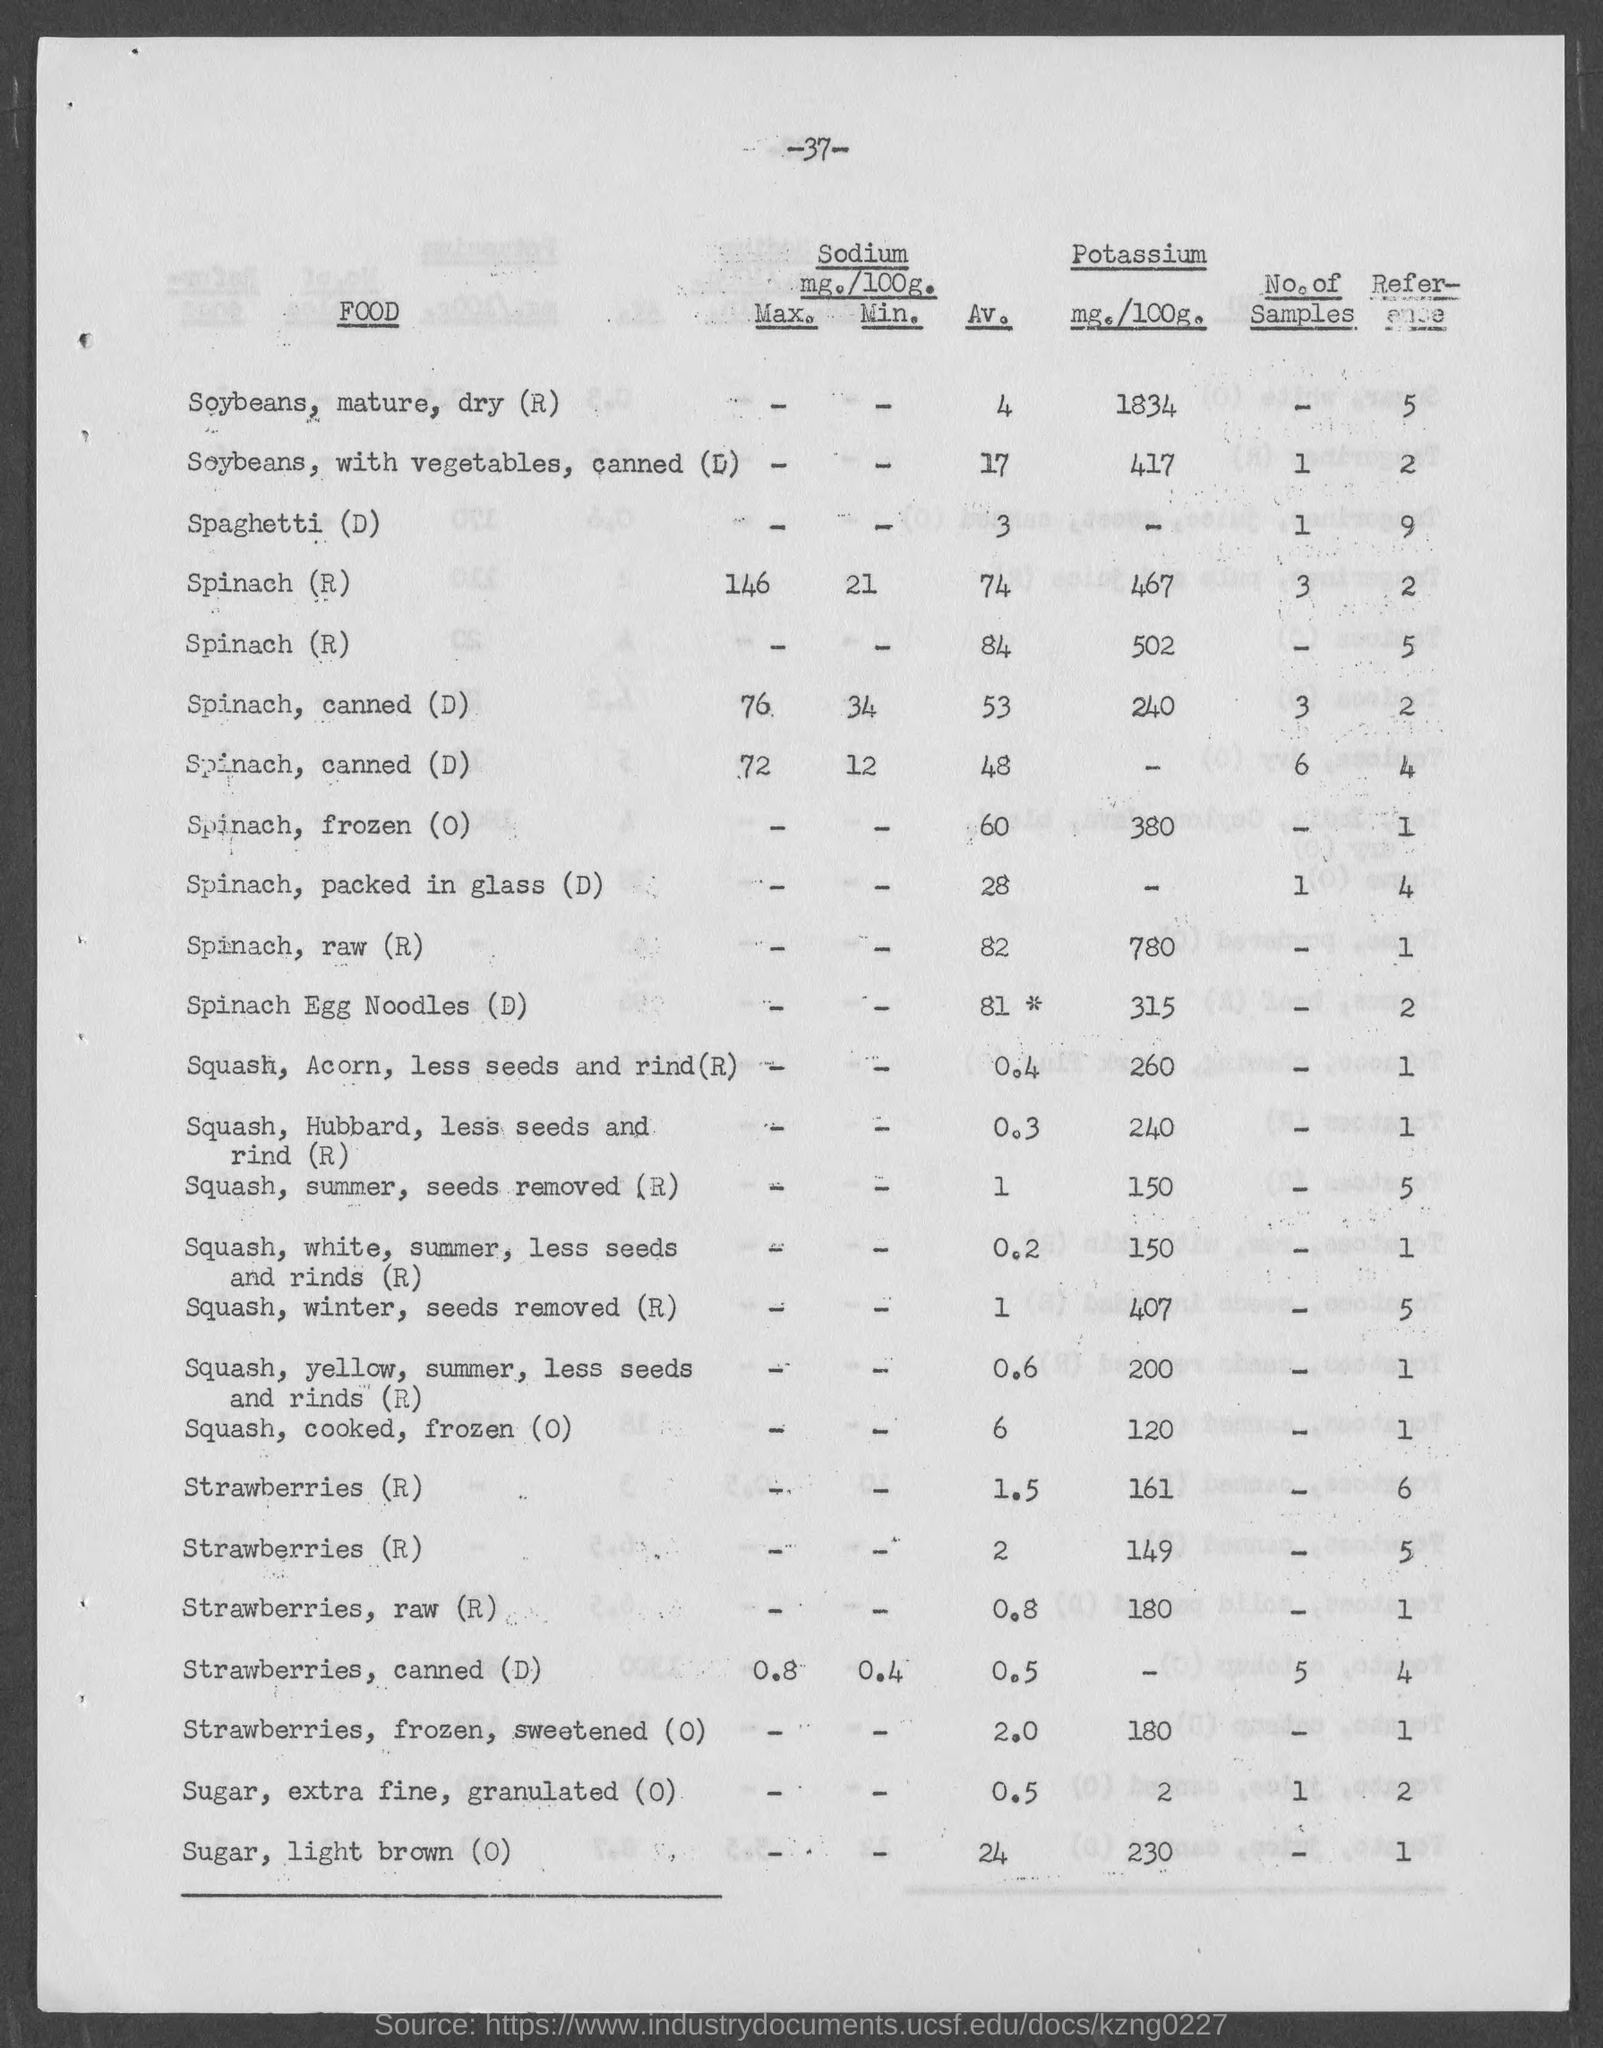What is the number at top of the page?
Offer a terse response. -37-. What is the amount of potassium mg./100g. for  soyabeans, mature, dry?
Provide a short and direct response. 1834. What is the amount of potassium mg./100g. for soybeans, with vegetables, canned ?
Provide a short and direct response. 417. What is the amount of potassium mg./100g. for spinach ,raw?
Give a very brief answer. 780. What is the amount of potassium mg./100g. for sugar, light brown?
Make the answer very short. 230. What is the amount of potassium mg./100g. for spinach, egg noodles?
Your answer should be very brief. 315. What is the amount of potassium mg./100g. for strawberries, raw?
Your response must be concise. 180. What is the amount of potassium mg./100g. for  sugar, extra fine, granulated ?
Offer a terse response. 2. What is the amount of potassium mg./100g. for squash, acorn, less seeds and rind ?
Provide a succinct answer. 260. What is the amount of potassium mg./100g. for squash, winter, seeds removed ?
Provide a succinct answer. 407. 